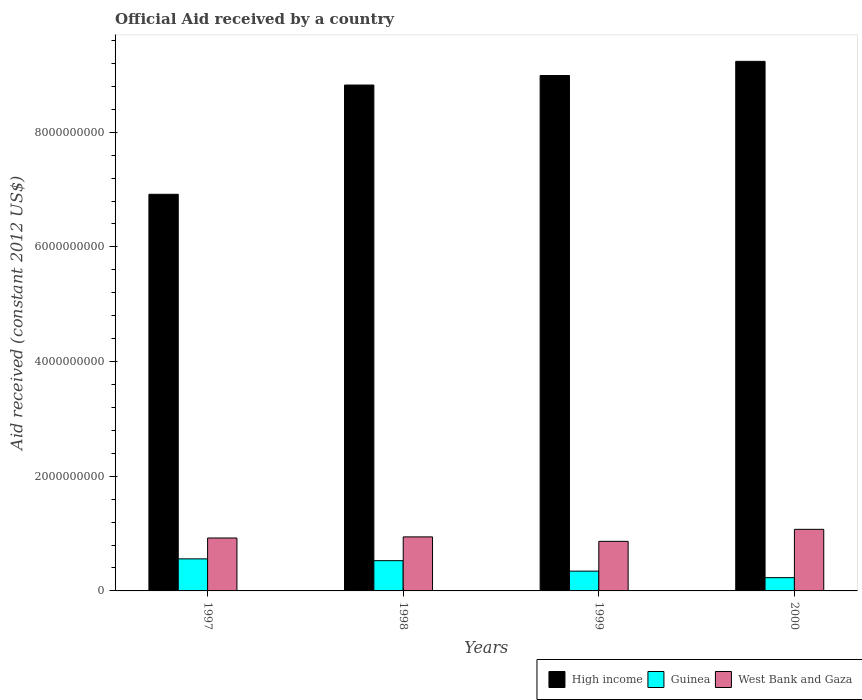How many different coloured bars are there?
Keep it short and to the point. 3. How many groups of bars are there?
Your answer should be compact. 4. Are the number of bars on each tick of the X-axis equal?
Your response must be concise. Yes. How many bars are there on the 4th tick from the right?
Provide a short and direct response. 3. What is the net official aid received in West Bank and Gaza in 1998?
Offer a very short reply. 9.42e+08. Across all years, what is the maximum net official aid received in West Bank and Gaza?
Offer a very short reply. 1.07e+09. Across all years, what is the minimum net official aid received in West Bank and Gaza?
Make the answer very short. 8.65e+08. In which year was the net official aid received in West Bank and Gaza maximum?
Keep it short and to the point. 2000. What is the total net official aid received in High income in the graph?
Your response must be concise. 3.40e+1. What is the difference between the net official aid received in High income in 1999 and that in 2000?
Ensure brevity in your answer.  -2.47e+08. What is the difference between the net official aid received in West Bank and Gaza in 2000 and the net official aid received in Guinea in 1998?
Your response must be concise. 5.46e+08. What is the average net official aid received in West Bank and Gaza per year?
Provide a succinct answer. 9.51e+08. In the year 2000, what is the difference between the net official aid received in Guinea and net official aid received in High income?
Provide a succinct answer. -9.00e+09. What is the ratio of the net official aid received in High income in 1997 to that in 2000?
Provide a short and direct response. 0.75. Is the net official aid received in West Bank and Gaza in 1998 less than that in 2000?
Offer a very short reply. Yes. What is the difference between the highest and the second highest net official aid received in West Bank and Gaza?
Make the answer very short. 1.32e+08. What is the difference between the highest and the lowest net official aid received in Guinea?
Your response must be concise. 3.28e+08. Is the sum of the net official aid received in High income in 1997 and 2000 greater than the maximum net official aid received in West Bank and Gaza across all years?
Give a very brief answer. Yes. What does the 3rd bar from the left in 1998 represents?
Make the answer very short. West Bank and Gaza. Is it the case that in every year, the sum of the net official aid received in West Bank and Gaza and net official aid received in High income is greater than the net official aid received in Guinea?
Your response must be concise. Yes. How many bars are there?
Keep it short and to the point. 12. Are all the bars in the graph horizontal?
Your answer should be compact. No. How many years are there in the graph?
Your answer should be compact. 4. What is the difference between two consecutive major ticks on the Y-axis?
Your answer should be compact. 2.00e+09. Are the values on the major ticks of Y-axis written in scientific E-notation?
Keep it short and to the point. No. Where does the legend appear in the graph?
Make the answer very short. Bottom right. How many legend labels are there?
Provide a short and direct response. 3. What is the title of the graph?
Give a very brief answer. Official Aid received by a country. Does "Costa Rica" appear as one of the legend labels in the graph?
Offer a very short reply. No. What is the label or title of the X-axis?
Give a very brief answer. Years. What is the label or title of the Y-axis?
Ensure brevity in your answer.  Aid received (constant 2012 US$). What is the Aid received (constant 2012 US$) in High income in 1997?
Make the answer very short. 6.92e+09. What is the Aid received (constant 2012 US$) in Guinea in 1997?
Your response must be concise. 5.59e+08. What is the Aid received (constant 2012 US$) in West Bank and Gaza in 1997?
Make the answer very short. 9.23e+08. What is the Aid received (constant 2012 US$) in High income in 1998?
Give a very brief answer. 8.82e+09. What is the Aid received (constant 2012 US$) in Guinea in 1998?
Offer a terse response. 5.28e+08. What is the Aid received (constant 2012 US$) in West Bank and Gaza in 1998?
Offer a terse response. 9.42e+08. What is the Aid received (constant 2012 US$) in High income in 1999?
Make the answer very short. 8.99e+09. What is the Aid received (constant 2012 US$) in Guinea in 1999?
Provide a short and direct response. 3.45e+08. What is the Aid received (constant 2012 US$) in West Bank and Gaza in 1999?
Ensure brevity in your answer.  8.65e+08. What is the Aid received (constant 2012 US$) of High income in 2000?
Offer a very short reply. 9.24e+09. What is the Aid received (constant 2012 US$) of Guinea in 2000?
Give a very brief answer. 2.32e+08. What is the Aid received (constant 2012 US$) in West Bank and Gaza in 2000?
Offer a terse response. 1.07e+09. Across all years, what is the maximum Aid received (constant 2012 US$) in High income?
Your answer should be very brief. 9.24e+09. Across all years, what is the maximum Aid received (constant 2012 US$) in Guinea?
Your response must be concise. 5.59e+08. Across all years, what is the maximum Aid received (constant 2012 US$) of West Bank and Gaza?
Keep it short and to the point. 1.07e+09. Across all years, what is the minimum Aid received (constant 2012 US$) in High income?
Keep it short and to the point. 6.92e+09. Across all years, what is the minimum Aid received (constant 2012 US$) of Guinea?
Provide a short and direct response. 2.32e+08. Across all years, what is the minimum Aid received (constant 2012 US$) in West Bank and Gaza?
Offer a very short reply. 8.65e+08. What is the total Aid received (constant 2012 US$) in High income in the graph?
Your response must be concise. 3.40e+1. What is the total Aid received (constant 2012 US$) of Guinea in the graph?
Offer a terse response. 1.66e+09. What is the total Aid received (constant 2012 US$) in West Bank and Gaza in the graph?
Provide a succinct answer. 3.80e+09. What is the difference between the Aid received (constant 2012 US$) in High income in 1997 and that in 1998?
Offer a terse response. -1.91e+09. What is the difference between the Aid received (constant 2012 US$) in Guinea in 1997 and that in 1998?
Make the answer very short. 3.14e+07. What is the difference between the Aid received (constant 2012 US$) in West Bank and Gaza in 1997 and that in 1998?
Your answer should be very brief. -1.93e+07. What is the difference between the Aid received (constant 2012 US$) in High income in 1997 and that in 1999?
Make the answer very short. -2.07e+09. What is the difference between the Aid received (constant 2012 US$) in Guinea in 1997 and that in 1999?
Provide a succinct answer. 2.14e+08. What is the difference between the Aid received (constant 2012 US$) of West Bank and Gaza in 1997 and that in 1999?
Offer a very short reply. 5.85e+07. What is the difference between the Aid received (constant 2012 US$) in High income in 1997 and that in 2000?
Offer a terse response. -2.32e+09. What is the difference between the Aid received (constant 2012 US$) of Guinea in 1997 and that in 2000?
Provide a succinct answer. 3.28e+08. What is the difference between the Aid received (constant 2012 US$) in West Bank and Gaza in 1997 and that in 2000?
Provide a succinct answer. -1.51e+08. What is the difference between the Aid received (constant 2012 US$) in High income in 1998 and that in 1999?
Your answer should be compact. -1.66e+08. What is the difference between the Aid received (constant 2012 US$) of Guinea in 1998 and that in 1999?
Offer a terse response. 1.82e+08. What is the difference between the Aid received (constant 2012 US$) in West Bank and Gaza in 1998 and that in 1999?
Your answer should be very brief. 7.77e+07. What is the difference between the Aid received (constant 2012 US$) in High income in 1998 and that in 2000?
Offer a very short reply. -4.13e+08. What is the difference between the Aid received (constant 2012 US$) of Guinea in 1998 and that in 2000?
Ensure brevity in your answer.  2.96e+08. What is the difference between the Aid received (constant 2012 US$) in West Bank and Gaza in 1998 and that in 2000?
Ensure brevity in your answer.  -1.32e+08. What is the difference between the Aid received (constant 2012 US$) in High income in 1999 and that in 2000?
Keep it short and to the point. -2.47e+08. What is the difference between the Aid received (constant 2012 US$) of Guinea in 1999 and that in 2000?
Make the answer very short. 1.14e+08. What is the difference between the Aid received (constant 2012 US$) in West Bank and Gaza in 1999 and that in 2000?
Offer a very short reply. -2.09e+08. What is the difference between the Aid received (constant 2012 US$) of High income in 1997 and the Aid received (constant 2012 US$) of Guinea in 1998?
Provide a succinct answer. 6.39e+09. What is the difference between the Aid received (constant 2012 US$) in High income in 1997 and the Aid received (constant 2012 US$) in West Bank and Gaza in 1998?
Your answer should be very brief. 5.98e+09. What is the difference between the Aid received (constant 2012 US$) in Guinea in 1997 and the Aid received (constant 2012 US$) in West Bank and Gaza in 1998?
Offer a very short reply. -3.83e+08. What is the difference between the Aid received (constant 2012 US$) of High income in 1997 and the Aid received (constant 2012 US$) of Guinea in 1999?
Keep it short and to the point. 6.57e+09. What is the difference between the Aid received (constant 2012 US$) in High income in 1997 and the Aid received (constant 2012 US$) in West Bank and Gaza in 1999?
Keep it short and to the point. 6.05e+09. What is the difference between the Aid received (constant 2012 US$) in Guinea in 1997 and the Aid received (constant 2012 US$) in West Bank and Gaza in 1999?
Your answer should be compact. -3.05e+08. What is the difference between the Aid received (constant 2012 US$) of High income in 1997 and the Aid received (constant 2012 US$) of Guinea in 2000?
Ensure brevity in your answer.  6.69e+09. What is the difference between the Aid received (constant 2012 US$) in High income in 1997 and the Aid received (constant 2012 US$) in West Bank and Gaza in 2000?
Your answer should be compact. 5.84e+09. What is the difference between the Aid received (constant 2012 US$) of Guinea in 1997 and the Aid received (constant 2012 US$) of West Bank and Gaza in 2000?
Give a very brief answer. -5.15e+08. What is the difference between the Aid received (constant 2012 US$) of High income in 1998 and the Aid received (constant 2012 US$) of Guinea in 1999?
Offer a very short reply. 8.48e+09. What is the difference between the Aid received (constant 2012 US$) of High income in 1998 and the Aid received (constant 2012 US$) of West Bank and Gaza in 1999?
Make the answer very short. 7.96e+09. What is the difference between the Aid received (constant 2012 US$) of Guinea in 1998 and the Aid received (constant 2012 US$) of West Bank and Gaza in 1999?
Offer a very short reply. -3.37e+08. What is the difference between the Aid received (constant 2012 US$) of High income in 1998 and the Aid received (constant 2012 US$) of Guinea in 2000?
Offer a very short reply. 8.59e+09. What is the difference between the Aid received (constant 2012 US$) of High income in 1998 and the Aid received (constant 2012 US$) of West Bank and Gaza in 2000?
Provide a short and direct response. 7.75e+09. What is the difference between the Aid received (constant 2012 US$) in Guinea in 1998 and the Aid received (constant 2012 US$) in West Bank and Gaza in 2000?
Offer a terse response. -5.46e+08. What is the difference between the Aid received (constant 2012 US$) of High income in 1999 and the Aid received (constant 2012 US$) of Guinea in 2000?
Offer a very short reply. 8.76e+09. What is the difference between the Aid received (constant 2012 US$) in High income in 1999 and the Aid received (constant 2012 US$) in West Bank and Gaza in 2000?
Provide a succinct answer. 7.91e+09. What is the difference between the Aid received (constant 2012 US$) in Guinea in 1999 and the Aid received (constant 2012 US$) in West Bank and Gaza in 2000?
Provide a short and direct response. -7.29e+08. What is the average Aid received (constant 2012 US$) in High income per year?
Your answer should be compact. 8.49e+09. What is the average Aid received (constant 2012 US$) of Guinea per year?
Offer a terse response. 4.16e+08. What is the average Aid received (constant 2012 US$) of West Bank and Gaza per year?
Your answer should be very brief. 9.51e+08. In the year 1997, what is the difference between the Aid received (constant 2012 US$) in High income and Aid received (constant 2012 US$) in Guinea?
Provide a succinct answer. 6.36e+09. In the year 1997, what is the difference between the Aid received (constant 2012 US$) of High income and Aid received (constant 2012 US$) of West Bank and Gaza?
Your answer should be compact. 5.99e+09. In the year 1997, what is the difference between the Aid received (constant 2012 US$) in Guinea and Aid received (constant 2012 US$) in West Bank and Gaza?
Offer a terse response. -3.64e+08. In the year 1998, what is the difference between the Aid received (constant 2012 US$) in High income and Aid received (constant 2012 US$) in Guinea?
Your answer should be compact. 8.29e+09. In the year 1998, what is the difference between the Aid received (constant 2012 US$) of High income and Aid received (constant 2012 US$) of West Bank and Gaza?
Provide a succinct answer. 7.88e+09. In the year 1998, what is the difference between the Aid received (constant 2012 US$) of Guinea and Aid received (constant 2012 US$) of West Bank and Gaza?
Ensure brevity in your answer.  -4.15e+08. In the year 1999, what is the difference between the Aid received (constant 2012 US$) of High income and Aid received (constant 2012 US$) of Guinea?
Your response must be concise. 8.64e+09. In the year 1999, what is the difference between the Aid received (constant 2012 US$) in High income and Aid received (constant 2012 US$) in West Bank and Gaza?
Ensure brevity in your answer.  8.12e+09. In the year 1999, what is the difference between the Aid received (constant 2012 US$) in Guinea and Aid received (constant 2012 US$) in West Bank and Gaza?
Offer a very short reply. -5.19e+08. In the year 2000, what is the difference between the Aid received (constant 2012 US$) of High income and Aid received (constant 2012 US$) of Guinea?
Your answer should be very brief. 9.00e+09. In the year 2000, what is the difference between the Aid received (constant 2012 US$) in High income and Aid received (constant 2012 US$) in West Bank and Gaza?
Your answer should be very brief. 8.16e+09. In the year 2000, what is the difference between the Aid received (constant 2012 US$) in Guinea and Aid received (constant 2012 US$) in West Bank and Gaza?
Your response must be concise. -8.42e+08. What is the ratio of the Aid received (constant 2012 US$) of High income in 1997 to that in 1998?
Ensure brevity in your answer.  0.78. What is the ratio of the Aid received (constant 2012 US$) in Guinea in 1997 to that in 1998?
Your answer should be very brief. 1.06. What is the ratio of the Aid received (constant 2012 US$) of West Bank and Gaza in 1997 to that in 1998?
Offer a very short reply. 0.98. What is the ratio of the Aid received (constant 2012 US$) in High income in 1997 to that in 1999?
Your answer should be very brief. 0.77. What is the ratio of the Aid received (constant 2012 US$) of Guinea in 1997 to that in 1999?
Your answer should be compact. 1.62. What is the ratio of the Aid received (constant 2012 US$) in West Bank and Gaza in 1997 to that in 1999?
Offer a very short reply. 1.07. What is the ratio of the Aid received (constant 2012 US$) of High income in 1997 to that in 2000?
Ensure brevity in your answer.  0.75. What is the ratio of the Aid received (constant 2012 US$) in Guinea in 1997 to that in 2000?
Ensure brevity in your answer.  2.41. What is the ratio of the Aid received (constant 2012 US$) in West Bank and Gaza in 1997 to that in 2000?
Make the answer very short. 0.86. What is the ratio of the Aid received (constant 2012 US$) of High income in 1998 to that in 1999?
Provide a succinct answer. 0.98. What is the ratio of the Aid received (constant 2012 US$) in Guinea in 1998 to that in 1999?
Give a very brief answer. 1.53. What is the ratio of the Aid received (constant 2012 US$) of West Bank and Gaza in 1998 to that in 1999?
Keep it short and to the point. 1.09. What is the ratio of the Aid received (constant 2012 US$) in High income in 1998 to that in 2000?
Your answer should be compact. 0.96. What is the ratio of the Aid received (constant 2012 US$) in Guinea in 1998 to that in 2000?
Your answer should be compact. 2.28. What is the ratio of the Aid received (constant 2012 US$) in West Bank and Gaza in 1998 to that in 2000?
Provide a short and direct response. 0.88. What is the ratio of the Aid received (constant 2012 US$) in High income in 1999 to that in 2000?
Offer a very short reply. 0.97. What is the ratio of the Aid received (constant 2012 US$) of Guinea in 1999 to that in 2000?
Provide a succinct answer. 1.49. What is the ratio of the Aid received (constant 2012 US$) in West Bank and Gaza in 1999 to that in 2000?
Offer a terse response. 0.81. What is the difference between the highest and the second highest Aid received (constant 2012 US$) of High income?
Keep it short and to the point. 2.47e+08. What is the difference between the highest and the second highest Aid received (constant 2012 US$) in Guinea?
Ensure brevity in your answer.  3.14e+07. What is the difference between the highest and the second highest Aid received (constant 2012 US$) of West Bank and Gaza?
Provide a succinct answer. 1.32e+08. What is the difference between the highest and the lowest Aid received (constant 2012 US$) in High income?
Make the answer very short. 2.32e+09. What is the difference between the highest and the lowest Aid received (constant 2012 US$) in Guinea?
Your answer should be very brief. 3.28e+08. What is the difference between the highest and the lowest Aid received (constant 2012 US$) in West Bank and Gaza?
Keep it short and to the point. 2.09e+08. 